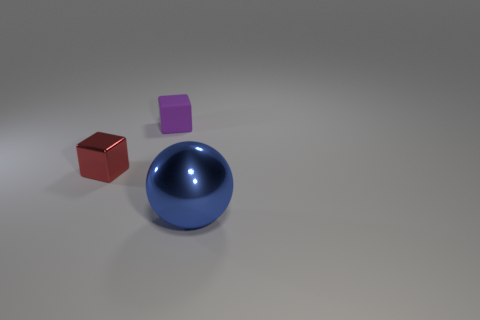There is a tiny purple block; what number of large blue shiny balls are behind it?
Your answer should be very brief. 0. How many other objects are the same color as the rubber block?
Make the answer very short. 0. Are there fewer blue things that are in front of the small red block than tiny metallic objects that are on the left side of the small purple block?
Provide a short and direct response. No. What number of objects are either tiny cubes that are behind the small red metallic object or purple matte blocks?
Your answer should be compact. 1. Do the matte block and the metal object that is behind the large blue object have the same size?
Provide a short and direct response. Yes. There is another red thing that is the same shape as the rubber object; what size is it?
Your answer should be very brief. Small. What number of spheres are to the left of the tiny thing behind the block that is to the left of the small rubber block?
Provide a short and direct response. 0. What number of cylinders are red objects or matte things?
Make the answer very short. 0. There is a shiny thing in front of the cube that is in front of the small thing that is to the right of the red thing; what is its color?
Your answer should be compact. Blue. How many other things are there of the same size as the blue metallic thing?
Keep it short and to the point. 0. 